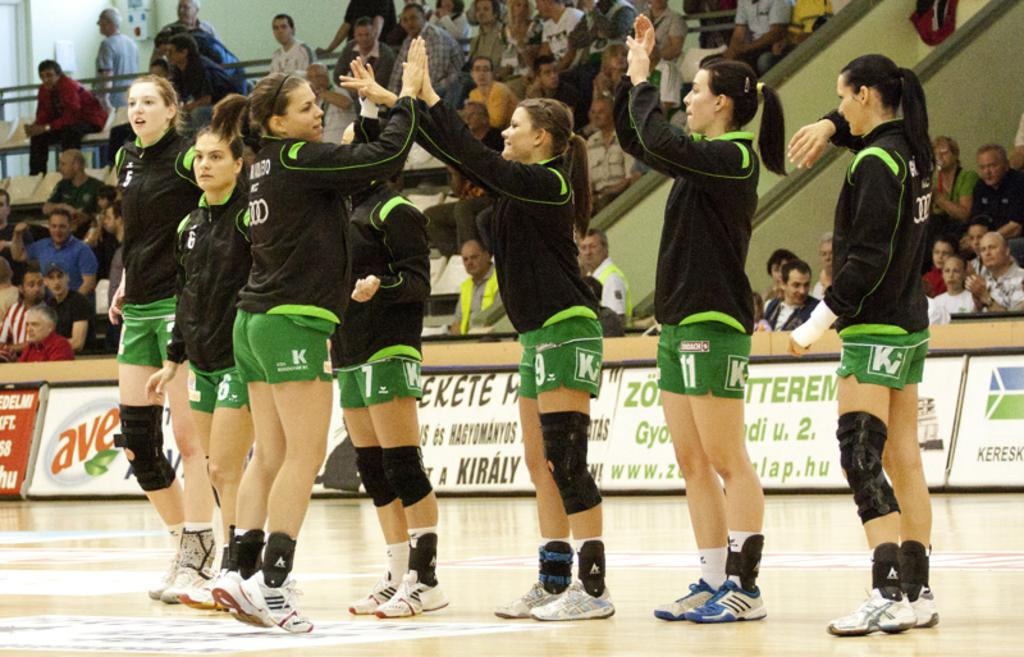<image>
Relay a brief, clear account of the picture shown. Female athletes wear shorts with the letter K on them. 